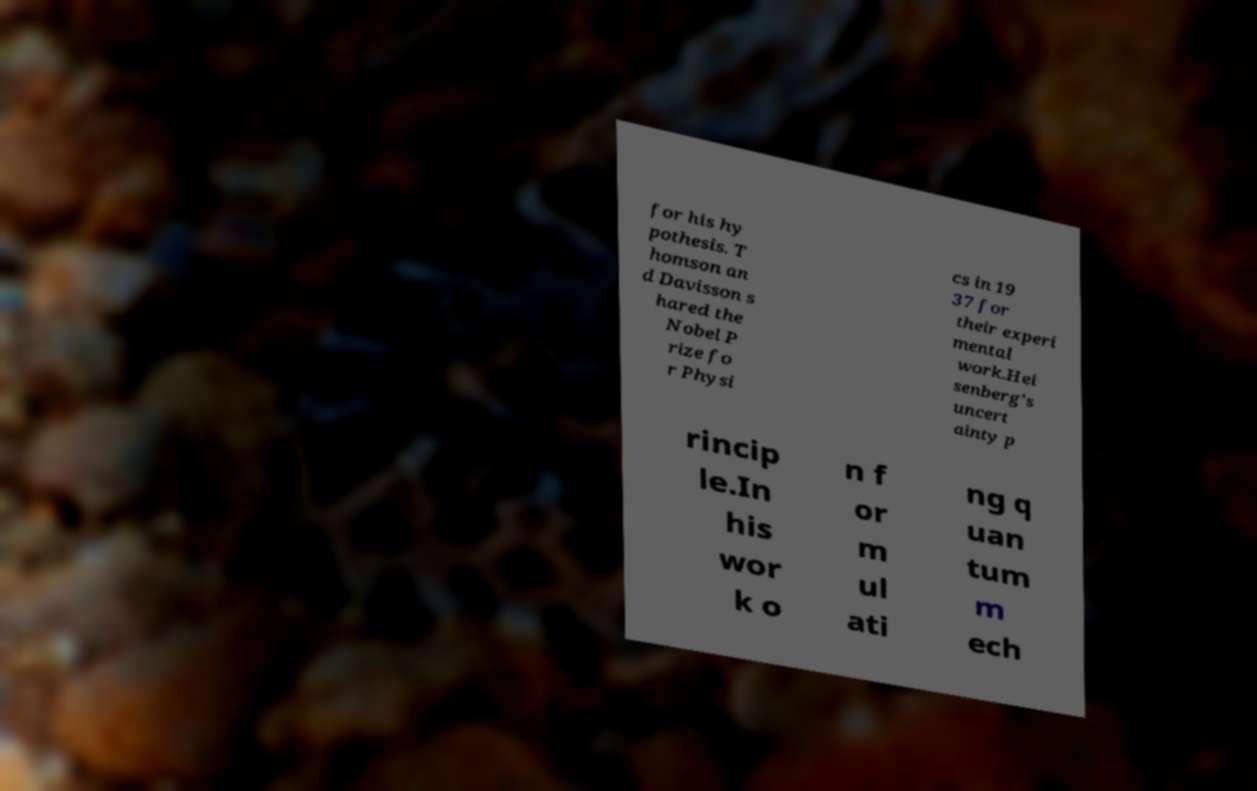Can you accurately transcribe the text from the provided image for me? for his hy pothesis. T homson an d Davisson s hared the Nobel P rize fo r Physi cs in 19 37 for their experi mental work.Hei senberg's uncert ainty p rincip le.In his wor k o n f or m ul ati ng q uan tum m ech 